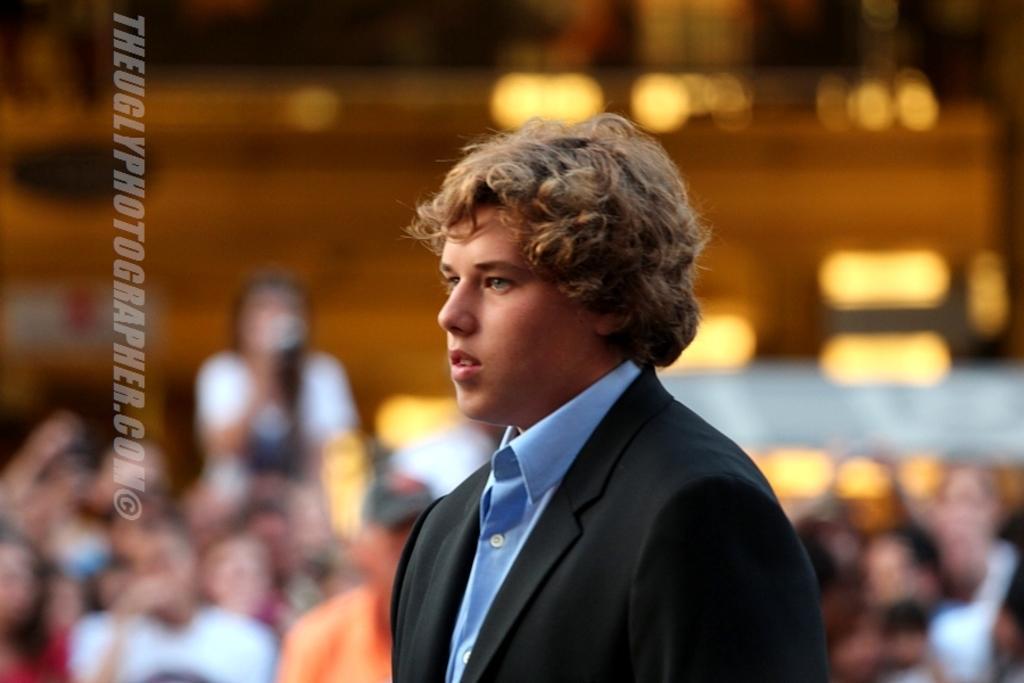Describe this image in one or two sentences. In this image we can see a person wearing blue shirt and a black coat, in the background there are few people at the back. 